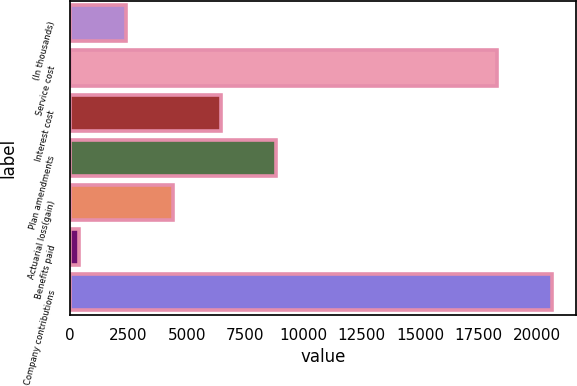<chart> <loc_0><loc_0><loc_500><loc_500><bar_chart><fcel>(In thousands)<fcel>Service cost<fcel>Interest cost<fcel>Plan amendments<fcel>Actuarial loss(gain)<fcel>Benefits paid<fcel>Company contributions<nl><fcel>2393.9<fcel>18291<fcel>6451.7<fcel>8834<fcel>4422.8<fcel>365<fcel>20654<nl></chart> 